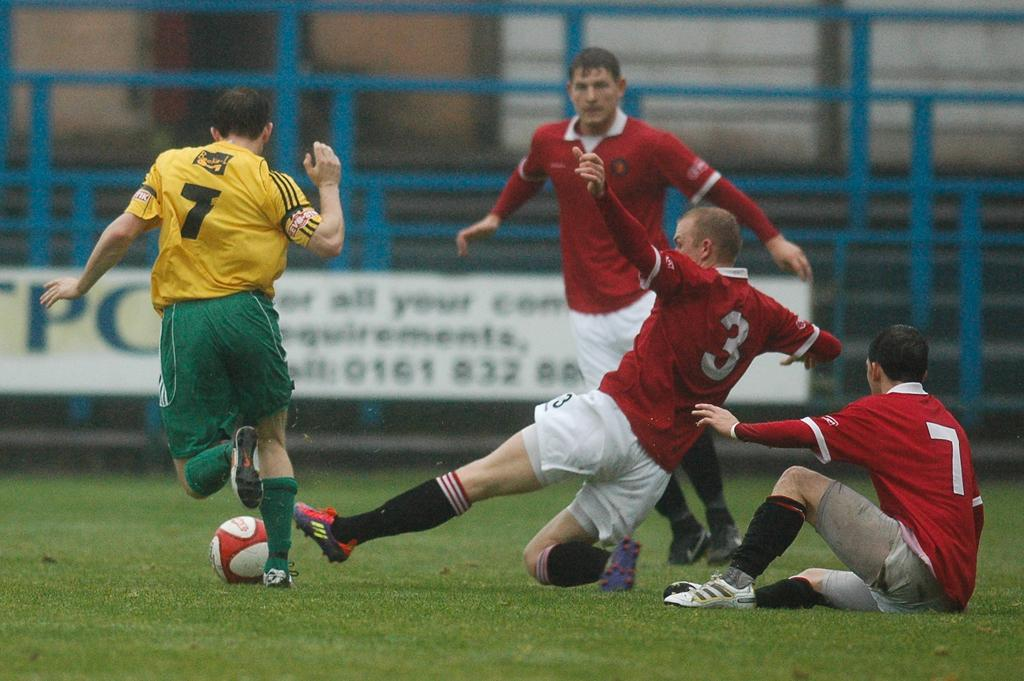<image>
Provide a brief description of the given image. a yellow jersey on a soccer player with the number 7 